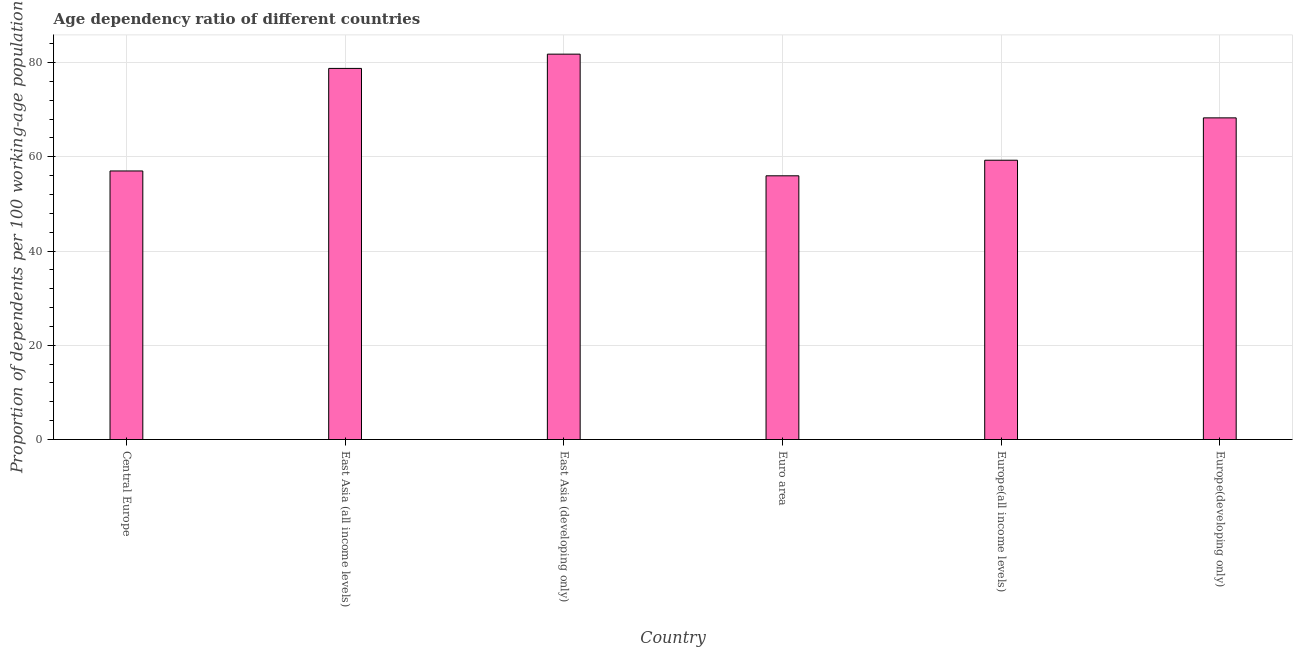What is the title of the graph?
Provide a succinct answer. Age dependency ratio of different countries. What is the label or title of the Y-axis?
Your answer should be very brief. Proportion of dependents per 100 working-age population. What is the age dependency ratio in Euro area?
Provide a succinct answer. 55.97. Across all countries, what is the maximum age dependency ratio?
Ensure brevity in your answer.  81.79. Across all countries, what is the minimum age dependency ratio?
Offer a very short reply. 55.97. In which country was the age dependency ratio maximum?
Your answer should be very brief. East Asia (developing only). In which country was the age dependency ratio minimum?
Offer a very short reply. Euro area. What is the sum of the age dependency ratio?
Your response must be concise. 401.07. What is the difference between the age dependency ratio in East Asia (all income levels) and Europe(all income levels)?
Your answer should be compact. 19.49. What is the average age dependency ratio per country?
Give a very brief answer. 66.84. What is the median age dependency ratio?
Your response must be concise. 63.77. What is the ratio of the age dependency ratio in Central Europe to that in East Asia (all income levels)?
Provide a short and direct response. 0.72. What is the difference between the highest and the second highest age dependency ratio?
Keep it short and to the point. 3.03. Is the sum of the age dependency ratio in East Asia (developing only) and Europe(developing only) greater than the maximum age dependency ratio across all countries?
Give a very brief answer. Yes. What is the difference between the highest and the lowest age dependency ratio?
Your response must be concise. 25.82. Are all the bars in the graph horizontal?
Offer a terse response. No. How many countries are there in the graph?
Offer a terse response. 6. What is the Proportion of dependents per 100 working-age population of Central Europe?
Keep it short and to the point. 57. What is the Proportion of dependents per 100 working-age population in East Asia (all income levels)?
Your answer should be compact. 78.76. What is the Proportion of dependents per 100 working-age population in East Asia (developing only)?
Offer a very short reply. 81.79. What is the Proportion of dependents per 100 working-age population of Euro area?
Make the answer very short. 55.97. What is the Proportion of dependents per 100 working-age population in Europe(all income levels)?
Offer a very short reply. 59.28. What is the Proportion of dependents per 100 working-age population of Europe(developing only)?
Your answer should be very brief. 68.27. What is the difference between the Proportion of dependents per 100 working-age population in Central Europe and East Asia (all income levels)?
Give a very brief answer. -21.76. What is the difference between the Proportion of dependents per 100 working-age population in Central Europe and East Asia (developing only)?
Offer a terse response. -24.79. What is the difference between the Proportion of dependents per 100 working-age population in Central Europe and Euro area?
Offer a very short reply. 1.03. What is the difference between the Proportion of dependents per 100 working-age population in Central Europe and Europe(all income levels)?
Provide a short and direct response. -2.28. What is the difference between the Proportion of dependents per 100 working-age population in Central Europe and Europe(developing only)?
Offer a very short reply. -11.27. What is the difference between the Proportion of dependents per 100 working-age population in East Asia (all income levels) and East Asia (developing only)?
Offer a terse response. -3.03. What is the difference between the Proportion of dependents per 100 working-age population in East Asia (all income levels) and Euro area?
Give a very brief answer. 22.79. What is the difference between the Proportion of dependents per 100 working-age population in East Asia (all income levels) and Europe(all income levels)?
Make the answer very short. 19.49. What is the difference between the Proportion of dependents per 100 working-age population in East Asia (all income levels) and Europe(developing only)?
Make the answer very short. 10.49. What is the difference between the Proportion of dependents per 100 working-age population in East Asia (developing only) and Euro area?
Give a very brief answer. 25.82. What is the difference between the Proportion of dependents per 100 working-age population in East Asia (developing only) and Europe(all income levels)?
Your response must be concise. 22.52. What is the difference between the Proportion of dependents per 100 working-age population in East Asia (developing only) and Europe(developing only)?
Keep it short and to the point. 13.52. What is the difference between the Proportion of dependents per 100 working-age population in Euro area and Europe(all income levels)?
Offer a terse response. -3.31. What is the difference between the Proportion of dependents per 100 working-age population in Euro area and Europe(developing only)?
Keep it short and to the point. -12.3. What is the difference between the Proportion of dependents per 100 working-age population in Europe(all income levels) and Europe(developing only)?
Your answer should be compact. -8.99. What is the ratio of the Proportion of dependents per 100 working-age population in Central Europe to that in East Asia (all income levels)?
Your answer should be compact. 0.72. What is the ratio of the Proportion of dependents per 100 working-age population in Central Europe to that in East Asia (developing only)?
Provide a short and direct response. 0.7. What is the ratio of the Proportion of dependents per 100 working-age population in Central Europe to that in Europe(developing only)?
Your answer should be compact. 0.83. What is the ratio of the Proportion of dependents per 100 working-age population in East Asia (all income levels) to that in Euro area?
Keep it short and to the point. 1.41. What is the ratio of the Proportion of dependents per 100 working-age population in East Asia (all income levels) to that in Europe(all income levels)?
Your answer should be very brief. 1.33. What is the ratio of the Proportion of dependents per 100 working-age population in East Asia (all income levels) to that in Europe(developing only)?
Give a very brief answer. 1.15. What is the ratio of the Proportion of dependents per 100 working-age population in East Asia (developing only) to that in Euro area?
Your response must be concise. 1.46. What is the ratio of the Proportion of dependents per 100 working-age population in East Asia (developing only) to that in Europe(all income levels)?
Your answer should be very brief. 1.38. What is the ratio of the Proportion of dependents per 100 working-age population in East Asia (developing only) to that in Europe(developing only)?
Give a very brief answer. 1.2. What is the ratio of the Proportion of dependents per 100 working-age population in Euro area to that in Europe(all income levels)?
Your answer should be very brief. 0.94. What is the ratio of the Proportion of dependents per 100 working-age population in Euro area to that in Europe(developing only)?
Keep it short and to the point. 0.82. What is the ratio of the Proportion of dependents per 100 working-age population in Europe(all income levels) to that in Europe(developing only)?
Keep it short and to the point. 0.87. 